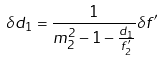<formula> <loc_0><loc_0><loc_500><loc_500>\delta d _ { 1 } = \frac { 1 } { m _ { 2 } ^ { 2 } - 1 - \frac { d _ { 1 } } { f ^ { \prime } _ { 2 } } } \delta f ^ { \prime }</formula> 